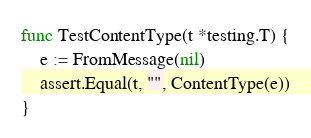Convert code to text. <code><loc_0><loc_0><loc_500><loc_500><_Go_>
func TestContentType(t *testing.T) {
	e := FromMessage(nil)
	assert.Equal(t, "", ContentType(e))
}
</code> 